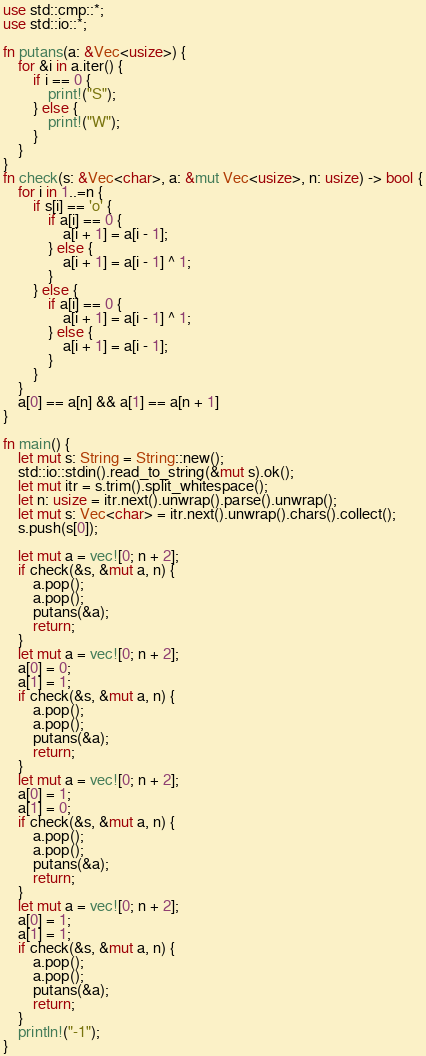Convert code to text. <code><loc_0><loc_0><loc_500><loc_500><_Rust_>use std::cmp::*;
use std::io::*;

fn putans(a: &Vec<usize>) {
    for &i in a.iter() {
        if i == 0 {
            print!("S");
        } else {
            print!("W");
        }
    }
}
fn check(s: &Vec<char>, a: &mut Vec<usize>, n: usize) -> bool {
    for i in 1..=n {
        if s[i] == 'o' {
            if a[i] == 0 {
                a[i + 1] = a[i - 1];
            } else {
                a[i + 1] = a[i - 1] ^ 1;
            }
        } else {
            if a[i] == 0 {
                a[i + 1] = a[i - 1] ^ 1;
            } else {
                a[i + 1] = a[i - 1];
            }
        }
    }
    a[0] == a[n] && a[1] == a[n + 1]
}

fn main() {
    let mut s: String = String::new();
    std::io::stdin().read_to_string(&mut s).ok();
    let mut itr = s.trim().split_whitespace();
    let n: usize = itr.next().unwrap().parse().unwrap();
    let mut s: Vec<char> = itr.next().unwrap().chars().collect();
    s.push(s[0]);

    let mut a = vec![0; n + 2];
    if check(&s, &mut a, n) {
        a.pop();
        a.pop();
        putans(&a);
        return;
    }
    let mut a = vec![0; n + 2];
    a[0] = 0;
    a[1] = 1;
    if check(&s, &mut a, n) {
        a.pop();
        a.pop();
        putans(&a);
        return;
    }
    let mut a = vec![0; n + 2];
    a[0] = 1;
    a[1] = 0;
    if check(&s, &mut a, n) {
        a.pop();
        a.pop();
        putans(&a);
        return;
    }
    let mut a = vec![0; n + 2];
    a[0] = 1;
    a[1] = 1;
    if check(&s, &mut a, n) {
        a.pop();
        a.pop();
        putans(&a);
        return;
    }
    println!("-1");
}
</code> 